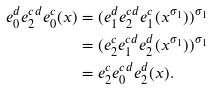Convert formula to latex. <formula><loc_0><loc_0><loc_500><loc_500>e ^ { d } _ { 0 } e ^ { c d } _ { 2 } e ^ { c } _ { 0 } ( x ) & = ( e ^ { d } _ { 1 } e ^ { c d } _ { 2 } e ^ { c } _ { 1 } ( x ^ { \sigma _ { 1 } } ) ) ^ { \sigma _ { 1 } } \\ & = ( e ^ { c } _ { 2 } e ^ { c d } _ { 1 } e ^ { d } _ { 2 } ( x ^ { \sigma _ { 1 } } ) ) ^ { \sigma _ { 1 } } \\ & = e ^ { c } _ { 2 } e ^ { c d } _ { 0 } e ^ { d } _ { 2 } ( x ) .</formula> 